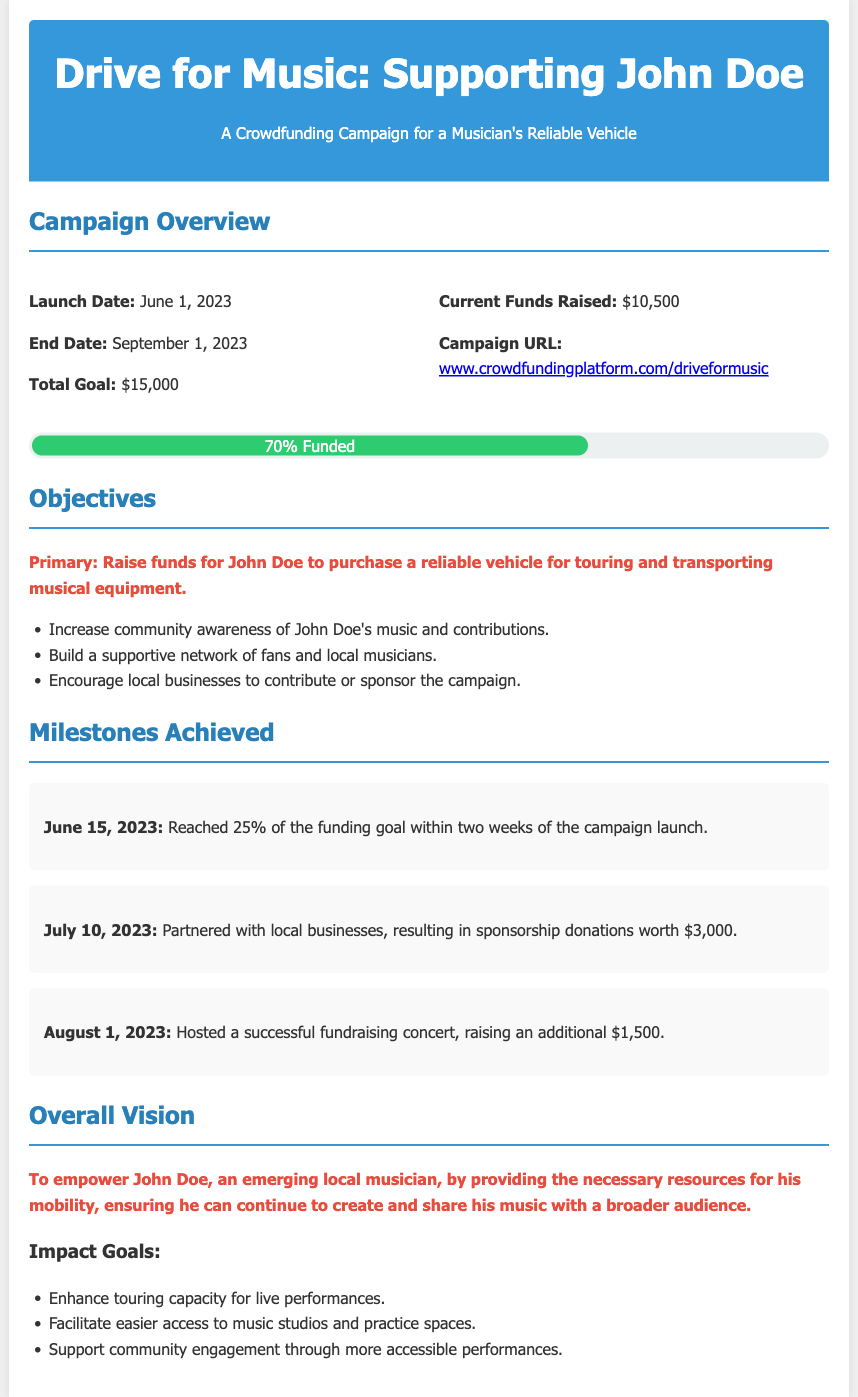what is the total goal? The total goal for the crowdfunding campaign is specified in the campaign overview section.
Answer: $15,000 when did the campaign launch? The launch date is mentioned in the Campaign Overview section.
Answer: June 1, 2023 how much has been raised so far? The current funds raised are listed under the Campaign Overview section.
Answer: $10,500 what percentage of the goal is currently funded? The progress section indicates the current percentage of the funding goal achieved.
Answer: 70% what is the primary objective of the campaign? The primary objective is highlighted in the objectives section of the document.
Answer: Raise funds for John Doe to purchase a reliable vehicle what milestone was achieved on July 10, 2023? The milestones section specifies the achievement on this date.
Answer: Partnered with local businesses, resulting in sponsorship donations worth $3,000 what was the outcome of the fundraising concert? The outcome of the concert is detailed in the milestones achieved section.
Answer: Raising an additional $1,500 what is the overall vision of the campaign? The overall vision is summarized in the vision section of the document.
Answer: To empower John Doe, an emerging local musician how many milestones are listed in the document? The milestones section provides multiple items that contribute to the total number of milestones achieved.
Answer: Three 